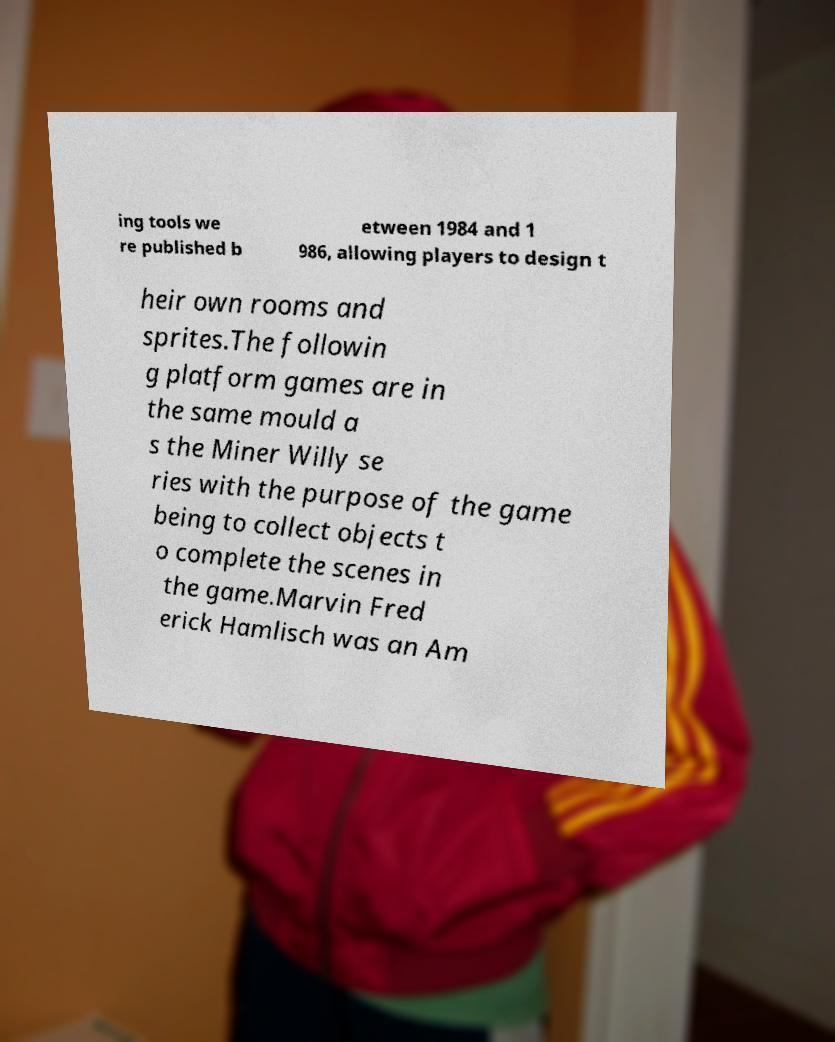Could you assist in decoding the text presented in this image and type it out clearly? ing tools we re published b etween 1984 and 1 986, allowing players to design t heir own rooms and sprites.The followin g platform games are in the same mould a s the Miner Willy se ries with the purpose of the game being to collect objects t o complete the scenes in the game.Marvin Fred erick Hamlisch was an Am 